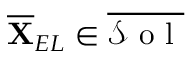<formula> <loc_0><loc_0><loc_500><loc_500>\overline { X } _ { E L } \in \overline { { \mathcal { S } o l } }</formula> 